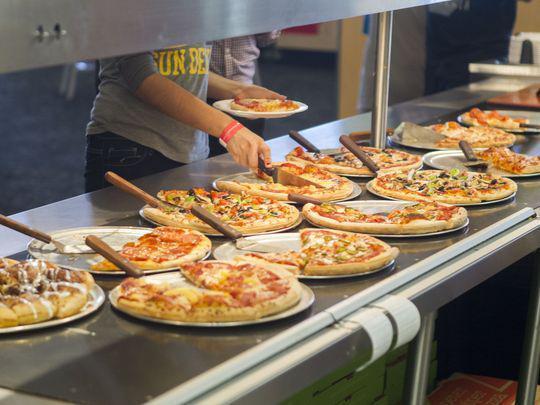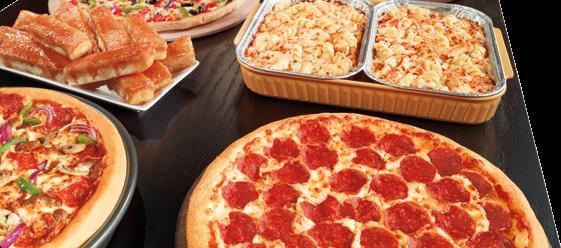The first image is the image on the left, the second image is the image on the right. Analyze the images presented: Is the assertion "There are no cut pizzas in the left image." valid? Answer yes or no. No. The first image is the image on the left, the second image is the image on the right. Assess this claim about the two images: "People stand along a buffet in one of the images.". Correct or not? Answer yes or no. Yes. 